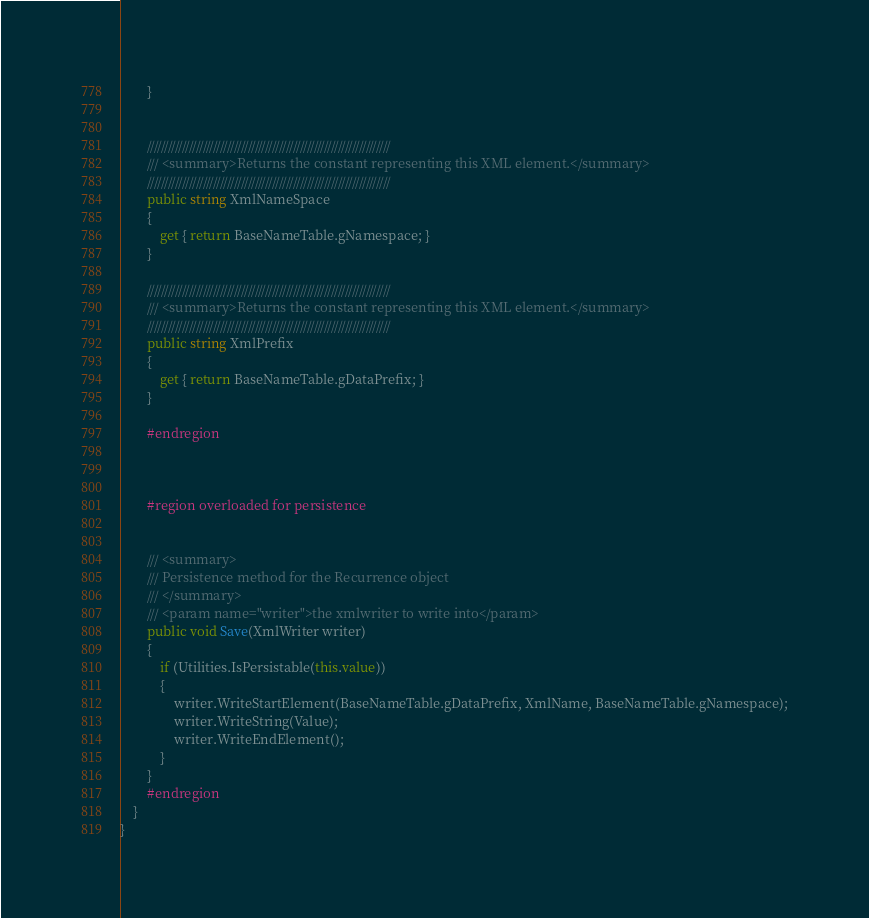<code> <loc_0><loc_0><loc_500><loc_500><_C#_>        }


        //////////////////////////////////////////////////////////////////////
        /// <summary>Returns the constant representing this XML element.</summary> 
        //////////////////////////////////////////////////////////////////////
        public string XmlNameSpace
        {
            get { return BaseNameTable.gNamespace; }
        }

        //////////////////////////////////////////////////////////////////////
        /// <summary>Returns the constant representing this XML element.</summary> 
        //////////////////////////////////////////////////////////////////////
        public string XmlPrefix
        {
            get { return BaseNameTable.gDataPrefix; }
        }

        #endregion



        #region overloaded for persistence


        /// <summary>
        /// Persistence method for the Recurrence object
        /// </summary>
        /// <param name="writer">the xmlwriter to write into</param>
        public void Save(XmlWriter writer)
        {
            if (Utilities.IsPersistable(this.value))
            {
                writer.WriteStartElement(BaseNameTable.gDataPrefix, XmlName, BaseNameTable.gNamespace);
                writer.WriteString(Value);
                writer.WriteEndElement();
            }
        }
        #endregion
    }
}
</code> 